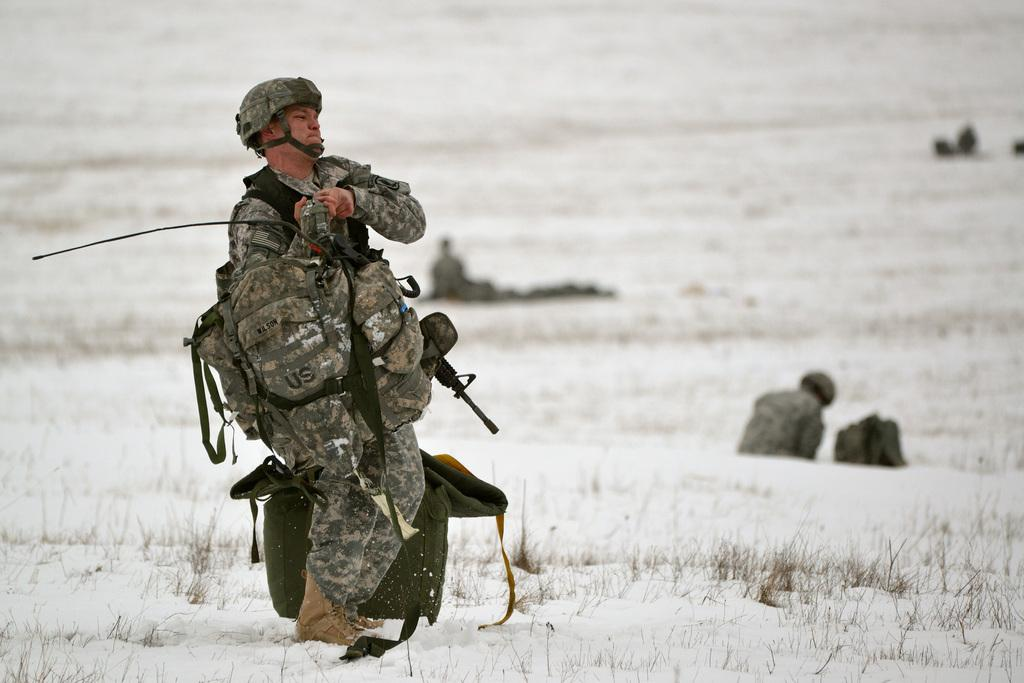What is the main subject of the image? There is a person in the image. What is the person wearing? The person is wearing a helmet. What is the person holding? The person is holding a gun. What else does the person have? The person has a bag. What is the surface the person is standing on? The person is standing on ice. What can be seen in the background of the image? There are people sitting on the ground in the background of the image. What type of crook can be seen on the stage in the image? There is no crook or stage present in the image; it features a person standing on ice with a helmet, gun, and bag. How many men are visible in the image? The image only shows one person, not multiple men. 